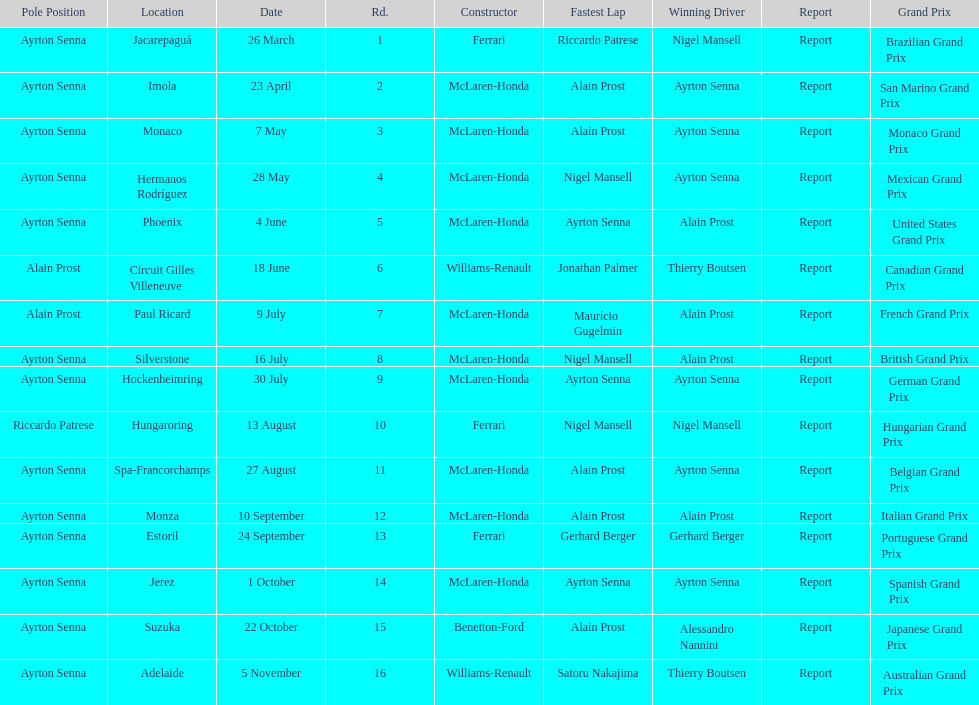Who won the spanish grand prix? McLaren-Honda. Who won the italian grand prix? McLaren-Honda. What grand prix did benneton-ford win? Japanese Grand Prix. 